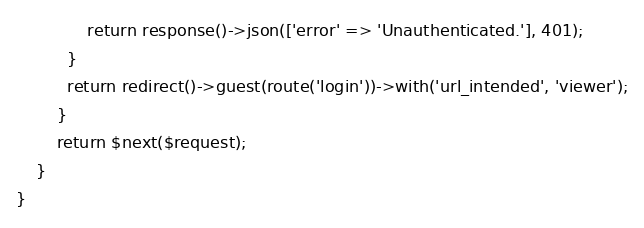Convert code to text. <code><loc_0><loc_0><loc_500><loc_500><_PHP_>              return response()->json(['error' => 'Unauthenticated.'], 401);
          }
          return redirect()->guest(route('login'))->with('url_intended', 'viewer');
        }
        return $next($request);
    }
}
</code> 